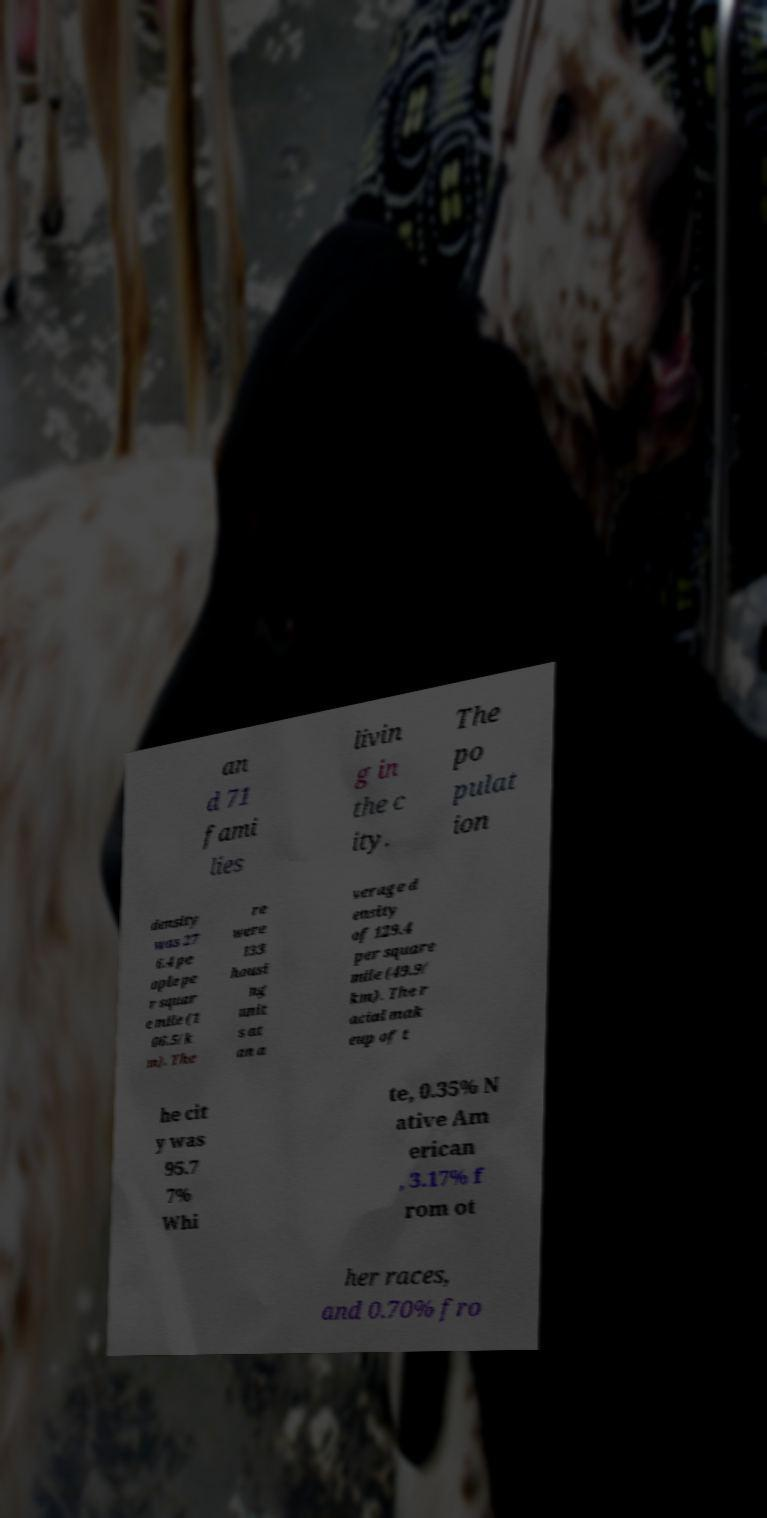Please read and relay the text visible in this image. What does it say? an d 71 fami lies livin g in the c ity. The po pulat ion density was 27 6.4 pe ople pe r squar e mile (1 06.5/k m). The re were 133 housi ng unit s at an a verage d ensity of 129.4 per square mile (49.9/ km). The r acial mak eup of t he cit y was 95.7 7% Whi te, 0.35% N ative Am erican , 3.17% f rom ot her races, and 0.70% fro 